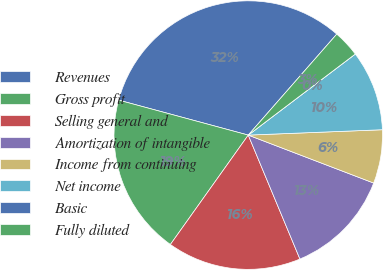Convert chart to OTSL. <chart><loc_0><loc_0><loc_500><loc_500><pie_chart><fcel>Revenues<fcel>Gross profit<fcel>Selling general and<fcel>Amortization of intangible<fcel>Income from continuing<fcel>Net income<fcel>Basic<fcel>Fully diluted<nl><fcel>32.26%<fcel>19.35%<fcel>16.13%<fcel>12.9%<fcel>6.45%<fcel>9.68%<fcel>0.0%<fcel>3.23%<nl></chart> 